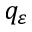Convert formula to latex. <formula><loc_0><loc_0><loc_500><loc_500>q _ { \varepsilon }</formula> 